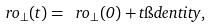<formula> <loc_0><loc_0><loc_500><loc_500>\ r o _ { \perp } ( t ) = \ r o _ { \perp } ( 0 ) + t \i d e n t i t y ,</formula> 